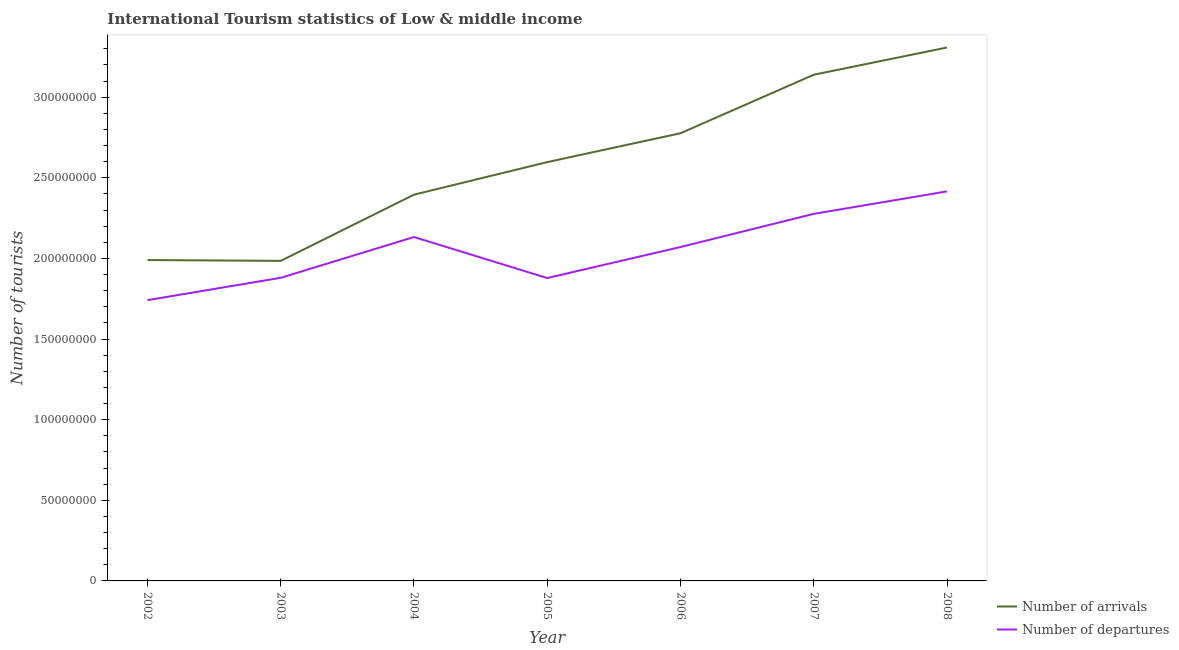Does the line corresponding to number of tourist arrivals intersect with the line corresponding to number of tourist departures?
Ensure brevity in your answer.  No. What is the number of tourist departures in 2005?
Make the answer very short. 1.88e+08. Across all years, what is the maximum number of tourist departures?
Make the answer very short. 2.42e+08. Across all years, what is the minimum number of tourist departures?
Offer a very short reply. 1.74e+08. What is the total number of tourist departures in the graph?
Offer a very short reply. 1.44e+09. What is the difference between the number of tourist departures in 2004 and that in 2008?
Offer a very short reply. -2.83e+07. What is the difference between the number of tourist departures in 2006 and the number of tourist arrivals in 2008?
Keep it short and to the point. -1.24e+08. What is the average number of tourist departures per year?
Your answer should be very brief. 2.06e+08. In the year 2008, what is the difference between the number of tourist departures and number of tourist arrivals?
Make the answer very short. -8.92e+07. In how many years, is the number of tourist departures greater than 200000000?
Make the answer very short. 4. What is the ratio of the number of tourist arrivals in 2003 to that in 2005?
Offer a very short reply. 0.76. Is the difference between the number of tourist arrivals in 2003 and 2004 greater than the difference between the number of tourist departures in 2003 and 2004?
Your answer should be compact. No. What is the difference between the highest and the second highest number of tourist departures?
Provide a short and direct response. 1.39e+07. What is the difference between the highest and the lowest number of tourist arrivals?
Give a very brief answer. 1.32e+08. In how many years, is the number of tourist departures greater than the average number of tourist departures taken over all years?
Give a very brief answer. 4. Does the number of tourist departures monotonically increase over the years?
Offer a terse response. No. Is the number of tourist arrivals strictly greater than the number of tourist departures over the years?
Offer a very short reply. Yes. Is the number of tourist departures strictly less than the number of tourist arrivals over the years?
Your answer should be very brief. Yes. How many lines are there?
Make the answer very short. 2. How many years are there in the graph?
Offer a terse response. 7. What is the difference between two consecutive major ticks on the Y-axis?
Your response must be concise. 5.00e+07. Does the graph contain grids?
Keep it short and to the point. No. Where does the legend appear in the graph?
Provide a short and direct response. Bottom right. How many legend labels are there?
Keep it short and to the point. 2. How are the legend labels stacked?
Keep it short and to the point. Vertical. What is the title of the graph?
Your response must be concise. International Tourism statistics of Low & middle income. Does "Commercial service exports" appear as one of the legend labels in the graph?
Make the answer very short. No. What is the label or title of the X-axis?
Ensure brevity in your answer.  Year. What is the label or title of the Y-axis?
Ensure brevity in your answer.  Number of tourists. What is the Number of tourists of Number of arrivals in 2002?
Ensure brevity in your answer.  1.99e+08. What is the Number of tourists in Number of departures in 2002?
Your answer should be very brief. 1.74e+08. What is the Number of tourists of Number of arrivals in 2003?
Your answer should be very brief. 1.98e+08. What is the Number of tourists of Number of departures in 2003?
Your answer should be compact. 1.88e+08. What is the Number of tourists of Number of arrivals in 2004?
Your answer should be very brief. 2.40e+08. What is the Number of tourists in Number of departures in 2004?
Your answer should be compact. 2.13e+08. What is the Number of tourists in Number of arrivals in 2005?
Your response must be concise. 2.60e+08. What is the Number of tourists of Number of departures in 2005?
Provide a short and direct response. 1.88e+08. What is the Number of tourists of Number of arrivals in 2006?
Ensure brevity in your answer.  2.78e+08. What is the Number of tourists of Number of departures in 2006?
Your answer should be very brief. 2.07e+08. What is the Number of tourists in Number of arrivals in 2007?
Provide a succinct answer. 3.14e+08. What is the Number of tourists of Number of departures in 2007?
Provide a succinct answer. 2.28e+08. What is the Number of tourists in Number of arrivals in 2008?
Your answer should be compact. 3.31e+08. What is the Number of tourists in Number of departures in 2008?
Make the answer very short. 2.42e+08. Across all years, what is the maximum Number of tourists in Number of arrivals?
Provide a short and direct response. 3.31e+08. Across all years, what is the maximum Number of tourists in Number of departures?
Provide a succinct answer. 2.42e+08. Across all years, what is the minimum Number of tourists of Number of arrivals?
Provide a short and direct response. 1.98e+08. Across all years, what is the minimum Number of tourists of Number of departures?
Ensure brevity in your answer.  1.74e+08. What is the total Number of tourists in Number of arrivals in the graph?
Give a very brief answer. 1.82e+09. What is the total Number of tourists of Number of departures in the graph?
Your answer should be very brief. 1.44e+09. What is the difference between the Number of tourists in Number of arrivals in 2002 and that in 2003?
Give a very brief answer. 5.22e+05. What is the difference between the Number of tourists of Number of departures in 2002 and that in 2003?
Make the answer very short. -1.39e+07. What is the difference between the Number of tourists in Number of arrivals in 2002 and that in 2004?
Your response must be concise. -4.05e+07. What is the difference between the Number of tourists in Number of departures in 2002 and that in 2004?
Offer a terse response. -3.92e+07. What is the difference between the Number of tourists in Number of arrivals in 2002 and that in 2005?
Keep it short and to the point. -6.07e+07. What is the difference between the Number of tourists of Number of departures in 2002 and that in 2005?
Offer a very short reply. -1.37e+07. What is the difference between the Number of tourists in Number of arrivals in 2002 and that in 2006?
Your answer should be compact. -7.86e+07. What is the difference between the Number of tourists in Number of departures in 2002 and that in 2006?
Your answer should be compact. -3.30e+07. What is the difference between the Number of tourists in Number of arrivals in 2002 and that in 2007?
Your response must be concise. -1.15e+08. What is the difference between the Number of tourists of Number of departures in 2002 and that in 2007?
Ensure brevity in your answer.  -5.35e+07. What is the difference between the Number of tourists of Number of arrivals in 2002 and that in 2008?
Your answer should be very brief. -1.32e+08. What is the difference between the Number of tourists of Number of departures in 2002 and that in 2008?
Your answer should be very brief. -6.75e+07. What is the difference between the Number of tourists in Number of arrivals in 2003 and that in 2004?
Provide a succinct answer. -4.11e+07. What is the difference between the Number of tourists of Number of departures in 2003 and that in 2004?
Your answer should be compact. -2.53e+07. What is the difference between the Number of tourists in Number of arrivals in 2003 and that in 2005?
Ensure brevity in your answer.  -6.12e+07. What is the difference between the Number of tourists in Number of departures in 2003 and that in 2005?
Give a very brief answer. 1.42e+05. What is the difference between the Number of tourists in Number of arrivals in 2003 and that in 2006?
Give a very brief answer. -7.92e+07. What is the difference between the Number of tourists in Number of departures in 2003 and that in 2006?
Your answer should be very brief. -1.91e+07. What is the difference between the Number of tourists of Number of arrivals in 2003 and that in 2007?
Ensure brevity in your answer.  -1.15e+08. What is the difference between the Number of tourists of Number of departures in 2003 and that in 2007?
Make the answer very short. -3.97e+07. What is the difference between the Number of tourists of Number of arrivals in 2003 and that in 2008?
Your answer should be very brief. -1.32e+08. What is the difference between the Number of tourists in Number of departures in 2003 and that in 2008?
Your response must be concise. -5.36e+07. What is the difference between the Number of tourists of Number of arrivals in 2004 and that in 2005?
Make the answer very short. -2.02e+07. What is the difference between the Number of tourists of Number of departures in 2004 and that in 2005?
Provide a short and direct response. 2.54e+07. What is the difference between the Number of tourists in Number of arrivals in 2004 and that in 2006?
Give a very brief answer. -3.81e+07. What is the difference between the Number of tourists of Number of departures in 2004 and that in 2006?
Provide a short and direct response. 6.20e+06. What is the difference between the Number of tourists in Number of arrivals in 2004 and that in 2007?
Provide a succinct answer. -7.44e+07. What is the difference between the Number of tourists of Number of departures in 2004 and that in 2007?
Provide a succinct answer. -1.44e+07. What is the difference between the Number of tourists in Number of arrivals in 2004 and that in 2008?
Provide a short and direct response. -9.13e+07. What is the difference between the Number of tourists in Number of departures in 2004 and that in 2008?
Make the answer very short. -2.83e+07. What is the difference between the Number of tourists of Number of arrivals in 2005 and that in 2006?
Give a very brief answer. -1.79e+07. What is the difference between the Number of tourists of Number of departures in 2005 and that in 2006?
Give a very brief answer. -1.92e+07. What is the difference between the Number of tourists in Number of arrivals in 2005 and that in 2007?
Give a very brief answer. -5.42e+07. What is the difference between the Number of tourists of Number of departures in 2005 and that in 2007?
Provide a succinct answer. -3.98e+07. What is the difference between the Number of tourists of Number of arrivals in 2005 and that in 2008?
Your answer should be compact. -7.11e+07. What is the difference between the Number of tourists of Number of departures in 2005 and that in 2008?
Your answer should be very brief. -5.37e+07. What is the difference between the Number of tourists of Number of arrivals in 2006 and that in 2007?
Your answer should be very brief. -3.63e+07. What is the difference between the Number of tourists in Number of departures in 2006 and that in 2007?
Offer a terse response. -2.06e+07. What is the difference between the Number of tourists in Number of arrivals in 2006 and that in 2008?
Keep it short and to the point. -5.32e+07. What is the difference between the Number of tourists in Number of departures in 2006 and that in 2008?
Give a very brief answer. -3.45e+07. What is the difference between the Number of tourists of Number of arrivals in 2007 and that in 2008?
Provide a short and direct response. -1.69e+07. What is the difference between the Number of tourists in Number of departures in 2007 and that in 2008?
Offer a terse response. -1.39e+07. What is the difference between the Number of tourists of Number of arrivals in 2002 and the Number of tourists of Number of departures in 2003?
Ensure brevity in your answer.  1.10e+07. What is the difference between the Number of tourists of Number of arrivals in 2002 and the Number of tourists of Number of departures in 2004?
Your answer should be very brief. -1.43e+07. What is the difference between the Number of tourists in Number of arrivals in 2002 and the Number of tourists in Number of departures in 2005?
Your answer should be very brief. 1.12e+07. What is the difference between the Number of tourists of Number of arrivals in 2002 and the Number of tourists of Number of departures in 2006?
Make the answer very short. -8.07e+06. What is the difference between the Number of tourists of Number of arrivals in 2002 and the Number of tourists of Number of departures in 2007?
Keep it short and to the point. -2.86e+07. What is the difference between the Number of tourists in Number of arrivals in 2002 and the Number of tourists in Number of departures in 2008?
Provide a short and direct response. -4.26e+07. What is the difference between the Number of tourists of Number of arrivals in 2003 and the Number of tourists of Number of departures in 2004?
Ensure brevity in your answer.  -1.48e+07. What is the difference between the Number of tourists in Number of arrivals in 2003 and the Number of tourists in Number of departures in 2005?
Your response must be concise. 1.07e+07. What is the difference between the Number of tourists of Number of arrivals in 2003 and the Number of tourists of Number of departures in 2006?
Offer a very short reply. -8.59e+06. What is the difference between the Number of tourists in Number of arrivals in 2003 and the Number of tourists in Number of departures in 2007?
Provide a succinct answer. -2.92e+07. What is the difference between the Number of tourists in Number of arrivals in 2003 and the Number of tourists in Number of departures in 2008?
Provide a succinct answer. -4.31e+07. What is the difference between the Number of tourists in Number of arrivals in 2004 and the Number of tourists in Number of departures in 2005?
Keep it short and to the point. 5.17e+07. What is the difference between the Number of tourists of Number of arrivals in 2004 and the Number of tourists of Number of departures in 2006?
Provide a succinct answer. 3.25e+07. What is the difference between the Number of tourists of Number of arrivals in 2004 and the Number of tourists of Number of departures in 2007?
Offer a terse response. 1.19e+07. What is the difference between the Number of tourists in Number of arrivals in 2004 and the Number of tourists in Number of departures in 2008?
Offer a terse response. -2.03e+06. What is the difference between the Number of tourists in Number of arrivals in 2005 and the Number of tourists in Number of departures in 2006?
Offer a very short reply. 5.27e+07. What is the difference between the Number of tourists in Number of arrivals in 2005 and the Number of tourists in Number of departures in 2007?
Offer a very short reply. 3.21e+07. What is the difference between the Number of tourists in Number of arrivals in 2005 and the Number of tourists in Number of departures in 2008?
Keep it short and to the point. 1.81e+07. What is the difference between the Number of tourists in Number of arrivals in 2006 and the Number of tourists in Number of departures in 2007?
Offer a terse response. 5.00e+07. What is the difference between the Number of tourists of Number of arrivals in 2006 and the Number of tourists of Number of departures in 2008?
Provide a short and direct response. 3.61e+07. What is the difference between the Number of tourists of Number of arrivals in 2007 and the Number of tourists of Number of departures in 2008?
Offer a very short reply. 7.23e+07. What is the average Number of tourists of Number of arrivals per year?
Ensure brevity in your answer.  2.60e+08. What is the average Number of tourists of Number of departures per year?
Ensure brevity in your answer.  2.06e+08. In the year 2002, what is the difference between the Number of tourists in Number of arrivals and Number of tourists in Number of departures?
Ensure brevity in your answer.  2.49e+07. In the year 2003, what is the difference between the Number of tourists in Number of arrivals and Number of tourists in Number of departures?
Ensure brevity in your answer.  1.05e+07. In the year 2004, what is the difference between the Number of tourists of Number of arrivals and Number of tourists of Number of departures?
Provide a succinct answer. 2.63e+07. In the year 2005, what is the difference between the Number of tourists in Number of arrivals and Number of tourists in Number of departures?
Your answer should be compact. 7.19e+07. In the year 2006, what is the difference between the Number of tourists in Number of arrivals and Number of tourists in Number of departures?
Keep it short and to the point. 7.06e+07. In the year 2007, what is the difference between the Number of tourists in Number of arrivals and Number of tourists in Number of departures?
Give a very brief answer. 8.63e+07. In the year 2008, what is the difference between the Number of tourists in Number of arrivals and Number of tourists in Number of departures?
Provide a short and direct response. 8.92e+07. What is the ratio of the Number of tourists in Number of departures in 2002 to that in 2003?
Give a very brief answer. 0.93. What is the ratio of the Number of tourists of Number of arrivals in 2002 to that in 2004?
Ensure brevity in your answer.  0.83. What is the ratio of the Number of tourists of Number of departures in 2002 to that in 2004?
Your response must be concise. 0.82. What is the ratio of the Number of tourists of Number of arrivals in 2002 to that in 2005?
Ensure brevity in your answer.  0.77. What is the ratio of the Number of tourists in Number of departures in 2002 to that in 2005?
Your response must be concise. 0.93. What is the ratio of the Number of tourists of Number of arrivals in 2002 to that in 2006?
Give a very brief answer. 0.72. What is the ratio of the Number of tourists of Number of departures in 2002 to that in 2006?
Your response must be concise. 0.84. What is the ratio of the Number of tourists of Number of arrivals in 2002 to that in 2007?
Your answer should be compact. 0.63. What is the ratio of the Number of tourists of Number of departures in 2002 to that in 2007?
Your response must be concise. 0.76. What is the ratio of the Number of tourists in Number of arrivals in 2002 to that in 2008?
Your answer should be very brief. 0.6. What is the ratio of the Number of tourists of Number of departures in 2002 to that in 2008?
Give a very brief answer. 0.72. What is the ratio of the Number of tourists in Number of arrivals in 2003 to that in 2004?
Ensure brevity in your answer.  0.83. What is the ratio of the Number of tourists in Number of departures in 2003 to that in 2004?
Your response must be concise. 0.88. What is the ratio of the Number of tourists in Number of arrivals in 2003 to that in 2005?
Keep it short and to the point. 0.76. What is the ratio of the Number of tourists in Number of arrivals in 2003 to that in 2006?
Provide a succinct answer. 0.71. What is the ratio of the Number of tourists in Number of departures in 2003 to that in 2006?
Provide a short and direct response. 0.91. What is the ratio of the Number of tourists in Number of arrivals in 2003 to that in 2007?
Make the answer very short. 0.63. What is the ratio of the Number of tourists of Number of departures in 2003 to that in 2007?
Provide a short and direct response. 0.83. What is the ratio of the Number of tourists in Number of arrivals in 2003 to that in 2008?
Provide a succinct answer. 0.6. What is the ratio of the Number of tourists of Number of departures in 2003 to that in 2008?
Offer a terse response. 0.78. What is the ratio of the Number of tourists of Number of arrivals in 2004 to that in 2005?
Ensure brevity in your answer.  0.92. What is the ratio of the Number of tourists in Number of departures in 2004 to that in 2005?
Keep it short and to the point. 1.14. What is the ratio of the Number of tourists in Number of arrivals in 2004 to that in 2006?
Provide a succinct answer. 0.86. What is the ratio of the Number of tourists in Number of departures in 2004 to that in 2006?
Provide a succinct answer. 1.03. What is the ratio of the Number of tourists in Number of arrivals in 2004 to that in 2007?
Provide a succinct answer. 0.76. What is the ratio of the Number of tourists in Number of departures in 2004 to that in 2007?
Your answer should be compact. 0.94. What is the ratio of the Number of tourists of Number of arrivals in 2004 to that in 2008?
Make the answer very short. 0.72. What is the ratio of the Number of tourists of Number of departures in 2004 to that in 2008?
Make the answer very short. 0.88. What is the ratio of the Number of tourists in Number of arrivals in 2005 to that in 2006?
Offer a very short reply. 0.94. What is the ratio of the Number of tourists of Number of departures in 2005 to that in 2006?
Make the answer very short. 0.91. What is the ratio of the Number of tourists of Number of arrivals in 2005 to that in 2007?
Offer a very short reply. 0.83. What is the ratio of the Number of tourists in Number of departures in 2005 to that in 2007?
Your answer should be very brief. 0.83. What is the ratio of the Number of tourists in Number of arrivals in 2005 to that in 2008?
Make the answer very short. 0.79. What is the ratio of the Number of tourists in Number of departures in 2005 to that in 2008?
Offer a terse response. 0.78. What is the ratio of the Number of tourists in Number of arrivals in 2006 to that in 2007?
Make the answer very short. 0.88. What is the ratio of the Number of tourists in Number of departures in 2006 to that in 2007?
Ensure brevity in your answer.  0.91. What is the ratio of the Number of tourists of Number of arrivals in 2006 to that in 2008?
Keep it short and to the point. 0.84. What is the ratio of the Number of tourists of Number of departures in 2006 to that in 2008?
Provide a succinct answer. 0.86. What is the ratio of the Number of tourists in Number of arrivals in 2007 to that in 2008?
Make the answer very short. 0.95. What is the ratio of the Number of tourists of Number of departures in 2007 to that in 2008?
Keep it short and to the point. 0.94. What is the difference between the highest and the second highest Number of tourists of Number of arrivals?
Make the answer very short. 1.69e+07. What is the difference between the highest and the second highest Number of tourists of Number of departures?
Offer a very short reply. 1.39e+07. What is the difference between the highest and the lowest Number of tourists of Number of arrivals?
Make the answer very short. 1.32e+08. What is the difference between the highest and the lowest Number of tourists in Number of departures?
Provide a short and direct response. 6.75e+07. 